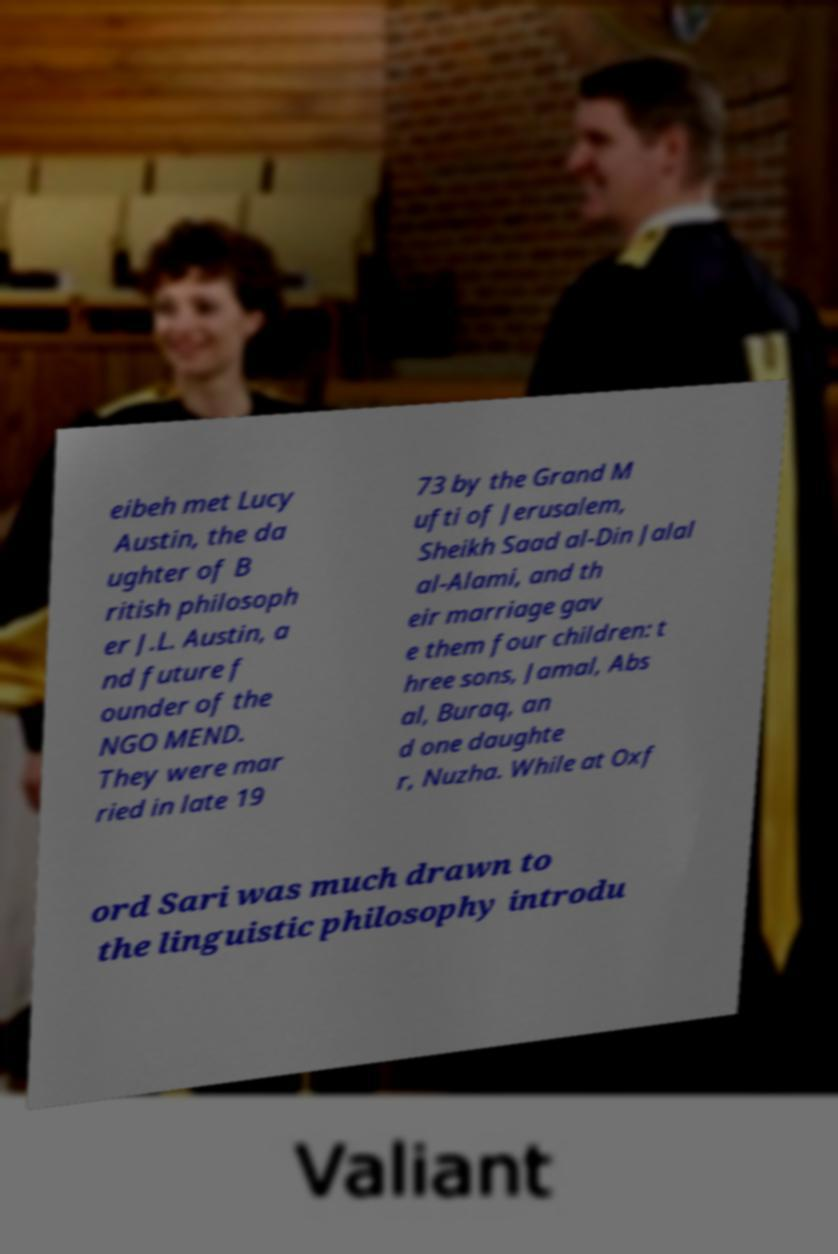Could you extract and type out the text from this image? eibeh met Lucy Austin, the da ughter of B ritish philosoph er J.L. Austin, a nd future f ounder of the NGO MEND. They were mar ried in late 19 73 by the Grand M ufti of Jerusalem, Sheikh Saad al-Din Jalal al-Alami, and th eir marriage gav e them four children: t hree sons, Jamal, Abs al, Buraq, an d one daughte r, Nuzha. While at Oxf ord Sari was much drawn to the linguistic philosophy introdu 